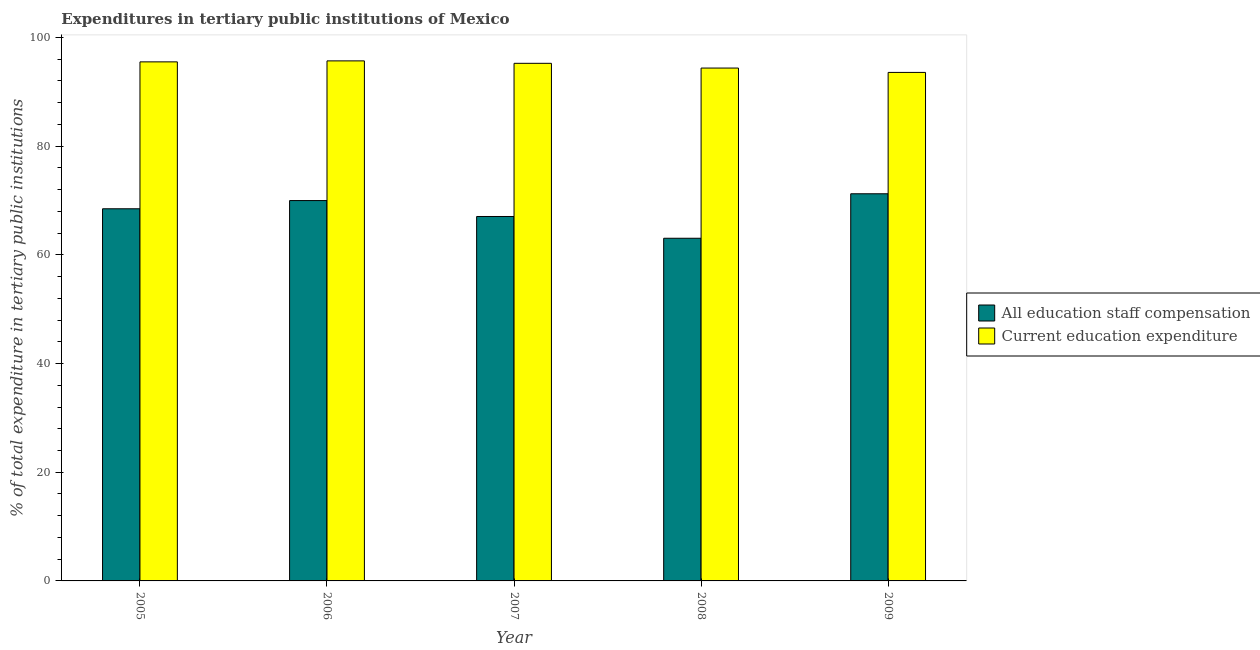How many groups of bars are there?
Your answer should be very brief. 5. Are the number of bars per tick equal to the number of legend labels?
Make the answer very short. Yes. What is the label of the 4th group of bars from the left?
Provide a short and direct response. 2008. In how many cases, is the number of bars for a given year not equal to the number of legend labels?
Offer a terse response. 0. What is the expenditure in staff compensation in 2009?
Ensure brevity in your answer.  71.23. Across all years, what is the maximum expenditure in education?
Offer a terse response. 95.68. Across all years, what is the minimum expenditure in education?
Provide a succinct answer. 93.56. In which year was the expenditure in staff compensation maximum?
Provide a succinct answer. 2009. What is the total expenditure in education in the graph?
Offer a terse response. 474.34. What is the difference between the expenditure in staff compensation in 2005 and that in 2007?
Your answer should be compact. 1.42. What is the difference between the expenditure in staff compensation in 2005 and the expenditure in education in 2006?
Keep it short and to the point. -1.51. What is the average expenditure in staff compensation per year?
Make the answer very short. 67.96. In the year 2005, what is the difference between the expenditure in education and expenditure in staff compensation?
Give a very brief answer. 0. In how many years, is the expenditure in staff compensation greater than 40 %?
Keep it short and to the point. 5. What is the ratio of the expenditure in education in 2007 to that in 2008?
Offer a very short reply. 1.01. Is the difference between the expenditure in staff compensation in 2006 and 2007 greater than the difference between the expenditure in education in 2006 and 2007?
Provide a short and direct response. No. What is the difference between the highest and the second highest expenditure in staff compensation?
Give a very brief answer. 1.25. What is the difference between the highest and the lowest expenditure in education?
Keep it short and to the point. 2.12. In how many years, is the expenditure in education greater than the average expenditure in education taken over all years?
Keep it short and to the point. 3. What does the 1st bar from the left in 2006 represents?
Your answer should be compact. All education staff compensation. What does the 2nd bar from the right in 2008 represents?
Provide a succinct answer. All education staff compensation. How many bars are there?
Make the answer very short. 10. Are all the bars in the graph horizontal?
Ensure brevity in your answer.  No. What is the difference between two consecutive major ticks on the Y-axis?
Keep it short and to the point. 20. Are the values on the major ticks of Y-axis written in scientific E-notation?
Your response must be concise. No. Does the graph contain grids?
Offer a terse response. No. Where does the legend appear in the graph?
Your answer should be compact. Center right. What is the title of the graph?
Your answer should be very brief. Expenditures in tertiary public institutions of Mexico. What is the label or title of the Y-axis?
Offer a very short reply. % of total expenditure in tertiary public institutions. What is the % of total expenditure in tertiary public institutions in All education staff compensation in 2005?
Your answer should be very brief. 68.47. What is the % of total expenditure in tertiary public institutions of Current education expenditure in 2005?
Your answer should be compact. 95.5. What is the % of total expenditure in tertiary public institutions of All education staff compensation in 2006?
Your answer should be very brief. 69.98. What is the % of total expenditure in tertiary public institutions in Current education expenditure in 2006?
Ensure brevity in your answer.  95.68. What is the % of total expenditure in tertiary public institutions of All education staff compensation in 2007?
Give a very brief answer. 67.05. What is the % of total expenditure in tertiary public institutions in Current education expenditure in 2007?
Ensure brevity in your answer.  95.23. What is the % of total expenditure in tertiary public institutions in All education staff compensation in 2008?
Provide a short and direct response. 63.05. What is the % of total expenditure in tertiary public institutions of Current education expenditure in 2008?
Offer a terse response. 94.36. What is the % of total expenditure in tertiary public institutions of All education staff compensation in 2009?
Provide a short and direct response. 71.23. What is the % of total expenditure in tertiary public institutions in Current education expenditure in 2009?
Provide a short and direct response. 93.56. Across all years, what is the maximum % of total expenditure in tertiary public institutions in All education staff compensation?
Your answer should be compact. 71.23. Across all years, what is the maximum % of total expenditure in tertiary public institutions in Current education expenditure?
Your answer should be compact. 95.68. Across all years, what is the minimum % of total expenditure in tertiary public institutions in All education staff compensation?
Your response must be concise. 63.05. Across all years, what is the minimum % of total expenditure in tertiary public institutions in Current education expenditure?
Give a very brief answer. 93.56. What is the total % of total expenditure in tertiary public institutions of All education staff compensation in the graph?
Ensure brevity in your answer.  339.79. What is the total % of total expenditure in tertiary public institutions of Current education expenditure in the graph?
Offer a terse response. 474.34. What is the difference between the % of total expenditure in tertiary public institutions of All education staff compensation in 2005 and that in 2006?
Provide a short and direct response. -1.51. What is the difference between the % of total expenditure in tertiary public institutions in Current education expenditure in 2005 and that in 2006?
Ensure brevity in your answer.  -0.18. What is the difference between the % of total expenditure in tertiary public institutions of All education staff compensation in 2005 and that in 2007?
Ensure brevity in your answer.  1.42. What is the difference between the % of total expenditure in tertiary public institutions in Current education expenditure in 2005 and that in 2007?
Keep it short and to the point. 0.27. What is the difference between the % of total expenditure in tertiary public institutions in All education staff compensation in 2005 and that in 2008?
Your response must be concise. 5.42. What is the difference between the % of total expenditure in tertiary public institutions in Current education expenditure in 2005 and that in 2008?
Your answer should be very brief. 1.14. What is the difference between the % of total expenditure in tertiary public institutions in All education staff compensation in 2005 and that in 2009?
Provide a short and direct response. -2.76. What is the difference between the % of total expenditure in tertiary public institutions in Current education expenditure in 2005 and that in 2009?
Give a very brief answer. 1.94. What is the difference between the % of total expenditure in tertiary public institutions in All education staff compensation in 2006 and that in 2007?
Your response must be concise. 2.93. What is the difference between the % of total expenditure in tertiary public institutions in Current education expenditure in 2006 and that in 2007?
Keep it short and to the point. 0.45. What is the difference between the % of total expenditure in tertiary public institutions of All education staff compensation in 2006 and that in 2008?
Offer a terse response. 6.93. What is the difference between the % of total expenditure in tertiary public institutions in Current education expenditure in 2006 and that in 2008?
Make the answer very short. 1.32. What is the difference between the % of total expenditure in tertiary public institutions in All education staff compensation in 2006 and that in 2009?
Provide a short and direct response. -1.25. What is the difference between the % of total expenditure in tertiary public institutions of Current education expenditure in 2006 and that in 2009?
Offer a terse response. 2.12. What is the difference between the % of total expenditure in tertiary public institutions of All education staff compensation in 2007 and that in 2008?
Ensure brevity in your answer.  4. What is the difference between the % of total expenditure in tertiary public institutions of Current education expenditure in 2007 and that in 2008?
Give a very brief answer. 0.87. What is the difference between the % of total expenditure in tertiary public institutions in All education staff compensation in 2007 and that in 2009?
Make the answer very short. -4.18. What is the difference between the % of total expenditure in tertiary public institutions in Current education expenditure in 2007 and that in 2009?
Make the answer very short. 1.67. What is the difference between the % of total expenditure in tertiary public institutions of All education staff compensation in 2008 and that in 2009?
Ensure brevity in your answer.  -8.18. What is the difference between the % of total expenditure in tertiary public institutions of Current education expenditure in 2008 and that in 2009?
Offer a very short reply. 0.8. What is the difference between the % of total expenditure in tertiary public institutions of All education staff compensation in 2005 and the % of total expenditure in tertiary public institutions of Current education expenditure in 2006?
Offer a terse response. -27.21. What is the difference between the % of total expenditure in tertiary public institutions in All education staff compensation in 2005 and the % of total expenditure in tertiary public institutions in Current education expenditure in 2007?
Your answer should be compact. -26.76. What is the difference between the % of total expenditure in tertiary public institutions of All education staff compensation in 2005 and the % of total expenditure in tertiary public institutions of Current education expenditure in 2008?
Your answer should be very brief. -25.89. What is the difference between the % of total expenditure in tertiary public institutions in All education staff compensation in 2005 and the % of total expenditure in tertiary public institutions in Current education expenditure in 2009?
Provide a short and direct response. -25.09. What is the difference between the % of total expenditure in tertiary public institutions of All education staff compensation in 2006 and the % of total expenditure in tertiary public institutions of Current education expenditure in 2007?
Your answer should be compact. -25.25. What is the difference between the % of total expenditure in tertiary public institutions in All education staff compensation in 2006 and the % of total expenditure in tertiary public institutions in Current education expenditure in 2008?
Your answer should be very brief. -24.38. What is the difference between the % of total expenditure in tertiary public institutions in All education staff compensation in 2006 and the % of total expenditure in tertiary public institutions in Current education expenditure in 2009?
Offer a terse response. -23.58. What is the difference between the % of total expenditure in tertiary public institutions in All education staff compensation in 2007 and the % of total expenditure in tertiary public institutions in Current education expenditure in 2008?
Your answer should be very brief. -27.31. What is the difference between the % of total expenditure in tertiary public institutions of All education staff compensation in 2007 and the % of total expenditure in tertiary public institutions of Current education expenditure in 2009?
Provide a short and direct response. -26.51. What is the difference between the % of total expenditure in tertiary public institutions in All education staff compensation in 2008 and the % of total expenditure in tertiary public institutions in Current education expenditure in 2009?
Offer a terse response. -30.51. What is the average % of total expenditure in tertiary public institutions of All education staff compensation per year?
Give a very brief answer. 67.96. What is the average % of total expenditure in tertiary public institutions of Current education expenditure per year?
Keep it short and to the point. 94.87. In the year 2005, what is the difference between the % of total expenditure in tertiary public institutions of All education staff compensation and % of total expenditure in tertiary public institutions of Current education expenditure?
Keep it short and to the point. -27.03. In the year 2006, what is the difference between the % of total expenditure in tertiary public institutions of All education staff compensation and % of total expenditure in tertiary public institutions of Current education expenditure?
Your answer should be very brief. -25.7. In the year 2007, what is the difference between the % of total expenditure in tertiary public institutions in All education staff compensation and % of total expenditure in tertiary public institutions in Current education expenditure?
Provide a succinct answer. -28.18. In the year 2008, what is the difference between the % of total expenditure in tertiary public institutions of All education staff compensation and % of total expenditure in tertiary public institutions of Current education expenditure?
Offer a terse response. -31.31. In the year 2009, what is the difference between the % of total expenditure in tertiary public institutions of All education staff compensation and % of total expenditure in tertiary public institutions of Current education expenditure?
Your response must be concise. -22.33. What is the ratio of the % of total expenditure in tertiary public institutions of All education staff compensation in 2005 to that in 2006?
Provide a short and direct response. 0.98. What is the ratio of the % of total expenditure in tertiary public institutions in Current education expenditure in 2005 to that in 2006?
Keep it short and to the point. 1. What is the ratio of the % of total expenditure in tertiary public institutions of All education staff compensation in 2005 to that in 2007?
Provide a succinct answer. 1.02. What is the ratio of the % of total expenditure in tertiary public institutions in All education staff compensation in 2005 to that in 2008?
Your answer should be very brief. 1.09. What is the ratio of the % of total expenditure in tertiary public institutions in Current education expenditure in 2005 to that in 2008?
Offer a very short reply. 1.01. What is the ratio of the % of total expenditure in tertiary public institutions in All education staff compensation in 2005 to that in 2009?
Offer a terse response. 0.96. What is the ratio of the % of total expenditure in tertiary public institutions in Current education expenditure in 2005 to that in 2009?
Offer a terse response. 1.02. What is the ratio of the % of total expenditure in tertiary public institutions of All education staff compensation in 2006 to that in 2007?
Your answer should be compact. 1.04. What is the ratio of the % of total expenditure in tertiary public institutions in All education staff compensation in 2006 to that in 2008?
Your answer should be compact. 1.11. What is the ratio of the % of total expenditure in tertiary public institutions of Current education expenditure in 2006 to that in 2008?
Offer a terse response. 1.01. What is the ratio of the % of total expenditure in tertiary public institutions of All education staff compensation in 2006 to that in 2009?
Keep it short and to the point. 0.98. What is the ratio of the % of total expenditure in tertiary public institutions of Current education expenditure in 2006 to that in 2009?
Make the answer very short. 1.02. What is the ratio of the % of total expenditure in tertiary public institutions in All education staff compensation in 2007 to that in 2008?
Make the answer very short. 1.06. What is the ratio of the % of total expenditure in tertiary public institutions of Current education expenditure in 2007 to that in 2008?
Your answer should be very brief. 1.01. What is the ratio of the % of total expenditure in tertiary public institutions of All education staff compensation in 2007 to that in 2009?
Your response must be concise. 0.94. What is the ratio of the % of total expenditure in tertiary public institutions in Current education expenditure in 2007 to that in 2009?
Keep it short and to the point. 1.02. What is the ratio of the % of total expenditure in tertiary public institutions of All education staff compensation in 2008 to that in 2009?
Keep it short and to the point. 0.89. What is the ratio of the % of total expenditure in tertiary public institutions of Current education expenditure in 2008 to that in 2009?
Keep it short and to the point. 1.01. What is the difference between the highest and the second highest % of total expenditure in tertiary public institutions of All education staff compensation?
Make the answer very short. 1.25. What is the difference between the highest and the second highest % of total expenditure in tertiary public institutions in Current education expenditure?
Give a very brief answer. 0.18. What is the difference between the highest and the lowest % of total expenditure in tertiary public institutions in All education staff compensation?
Keep it short and to the point. 8.18. What is the difference between the highest and the lowest % of total expenditure in tertiary public institutions of Current education expenditure?
Provide a succinct answer. 2.12. 